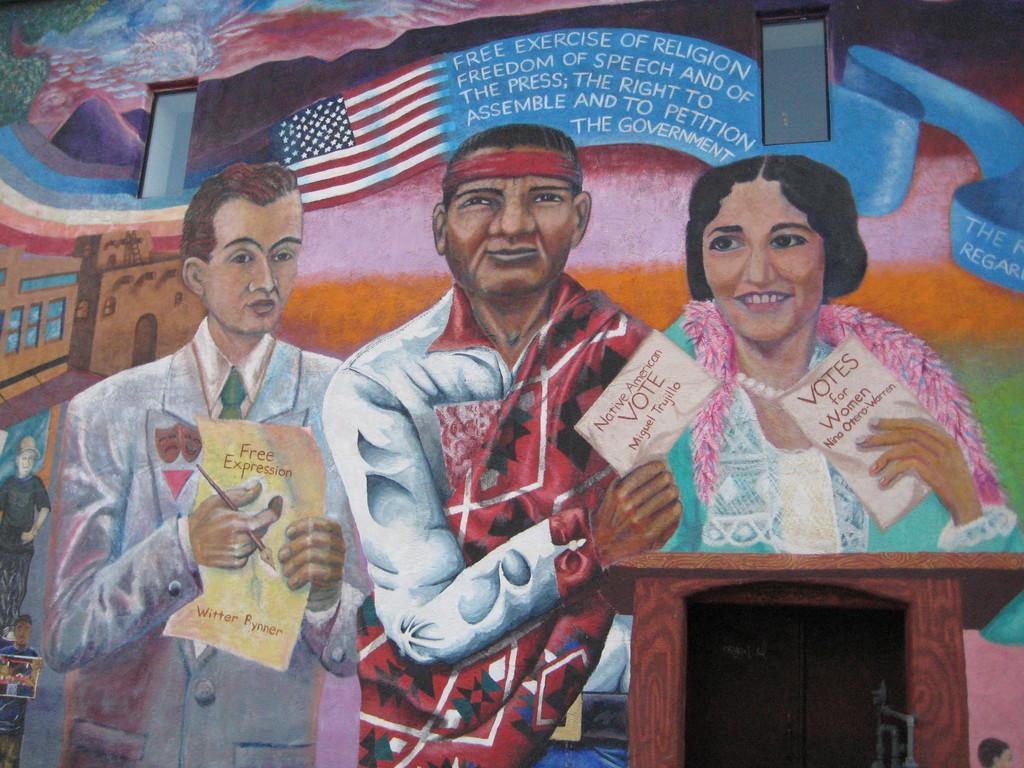How would you summarize this image in a sentence or two? In this picture we can see painting of 3 people standing in front of a podium and holding paper in their hands. In the background, we can see the US flag. 